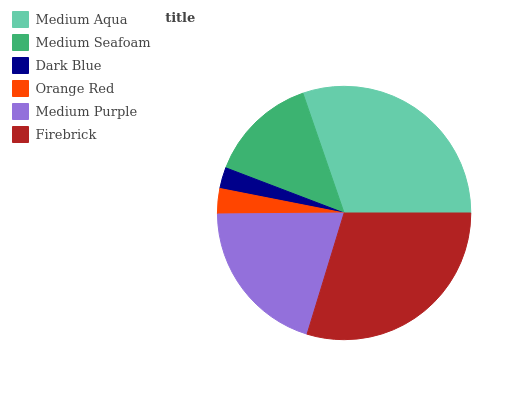Is Dark Blue the minimum?
Answer yes or no. Yes. Is Medium Aqua the maximum?
Answer yes or no. Yes. Is Medium Seafoam the minimum?
Answer yes or no. No. Is Medium Seafoam the maximum?
Answer yes or no. No. Is Medium Aqua greater than Medium Seafoam?
Answer yes or no. Yes. Is Medium Seafoam less than Medium Aqua?
Answer yes or no. Yes. Is Medium Seafoam greater than Medium Aqua?
Answer yes or no. No. Is Medium Aqua less than Medium Seafoam?
Answer yes or no. No. Is Medium Purple the high median?
Answer yes or no. Yes. Is Medium Seafoam the low median?
Answer yes or no. Yes. Is Firebrick the high median?
Answer yes or no. No. Is Dark Blue the low median?
Answer yes or no. No. 